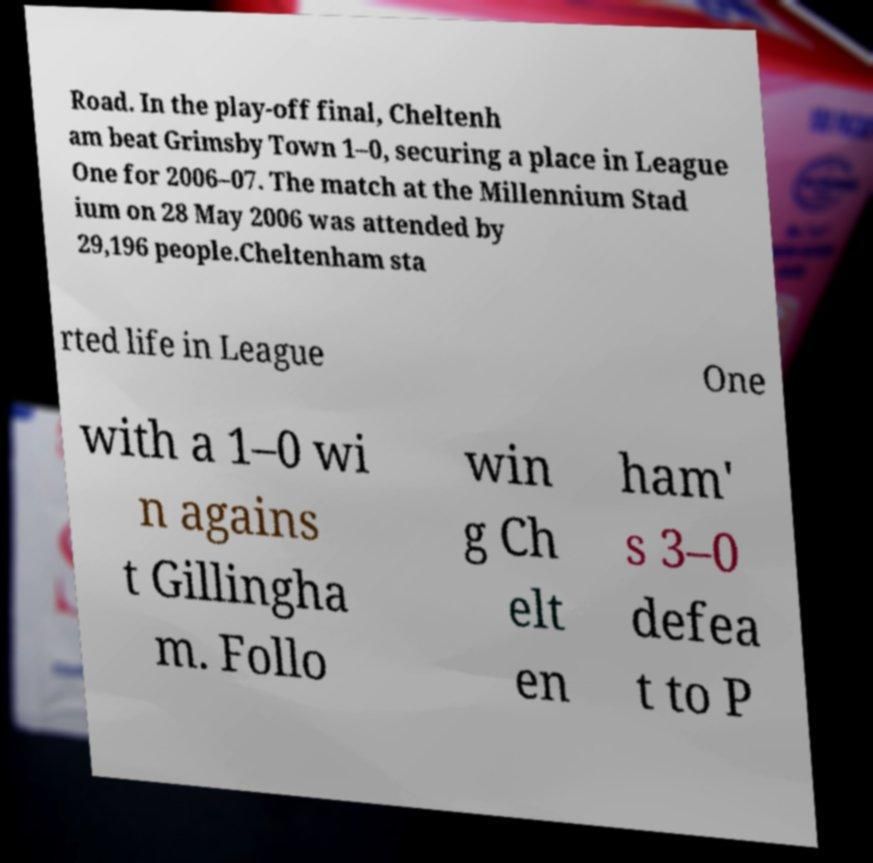Please read and relay the text visible in this image. What does it say? Road. In the play-off final, Cheltenh am beat Grimsby Town 1–0, securing a place in League One for 2006–07. The match at the Millennium Stad ium on 28 May 2006 was attended by 29,196 people.Cheltenham sta rted life in League One with a 1–0 wi n agains t Gillingha m. Follo win g Ch elt en ham' s 3–0 defea t to P 